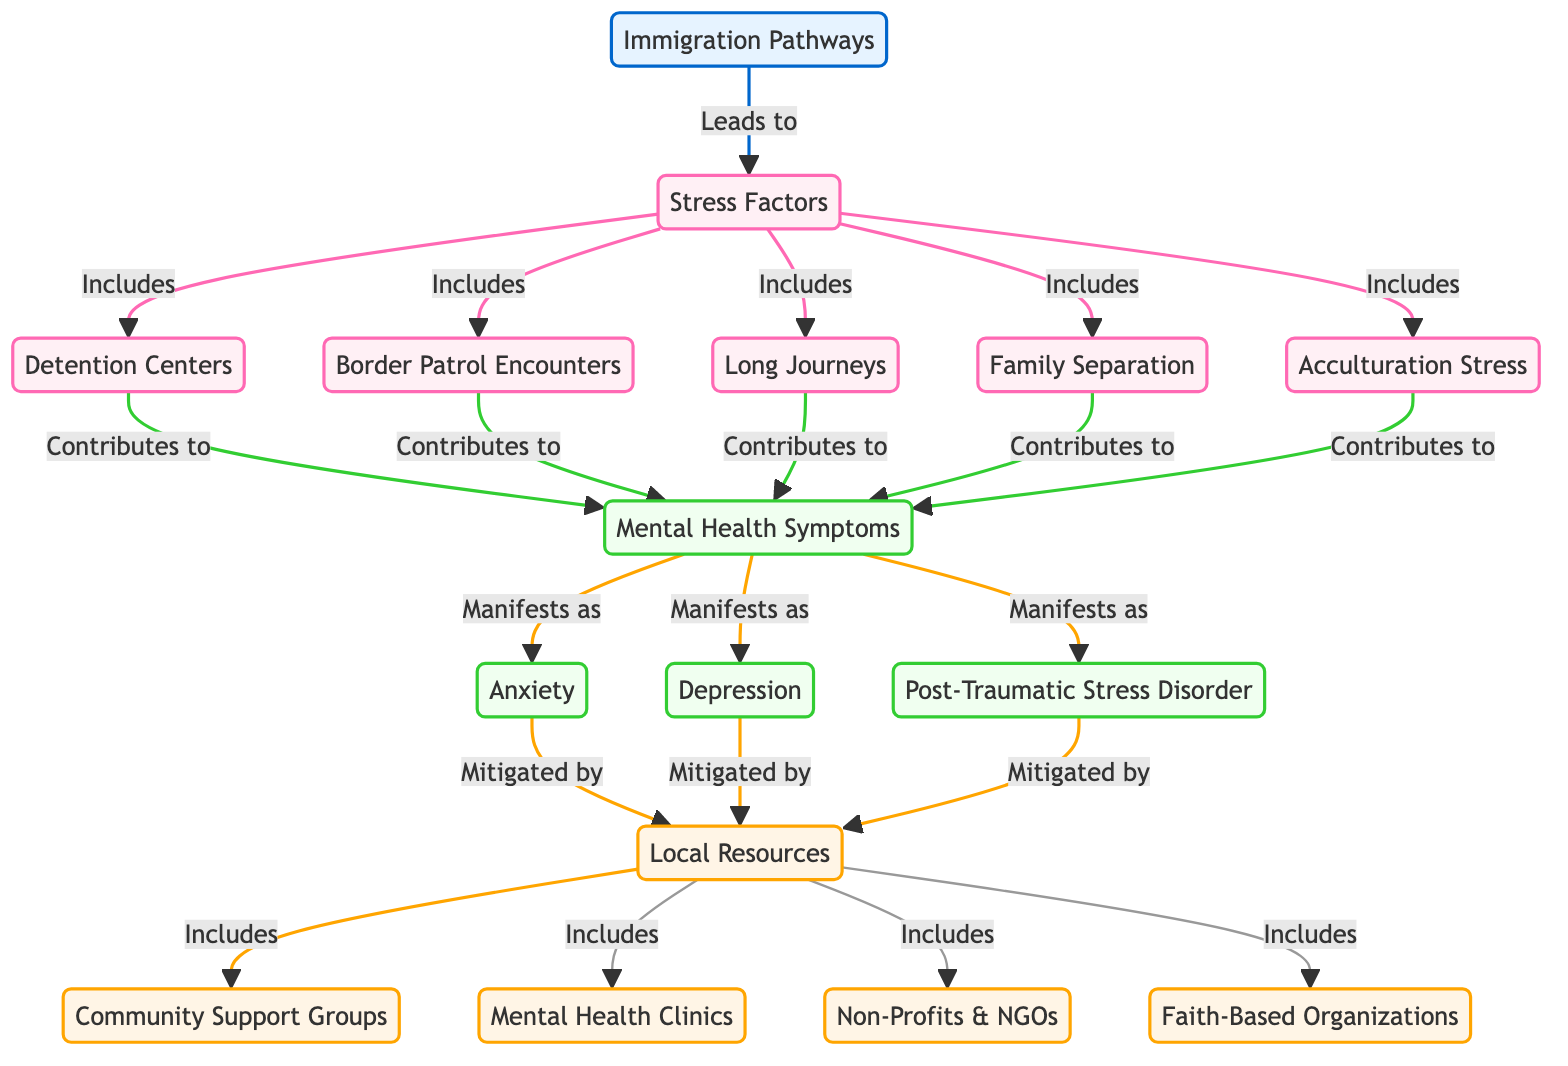What are the main stress factors related to immigration? The diagram lists the stress factors as: Detention Centers, Border Patrol Encounters, Long Journeys, Family Separation, and Acculturation Stress. These factors directly connect to the "Stress Factors" node, indicating they are crucial contributors to overall stress experienced by migrants.
Answer: Detention Centers, Border Patrol Encounters, Long Journeys, Family Separation, Acculturation Stress How many local resources are identified in the diagram? The diagram specifies four local resources: Community Support Groups, Mental Health Clinics, Non-Profits & NGOs, and Faith-Based Organizations. These are all linked to the "Local Resources" node, confirming they are vital support options available.
Answer: Four What symptoms are associated with mental health issues in migrants? The symptoms indicated in the diagram are Anxiety, Depression, and Post-Traumatic Stress Disorder. Each of these is connected to the "Mental Health Symptoms" node, demonstrating their significance in the context of mental health for migrants.
Answer: Anxiety, Depression, Post-Traumatic Stress Disorder Which stress factor contributes to mental health symptoms? Detention Centers, Border Patrol Encounters, Long Journeys, Family Separation, and Acculturation Stress are the factors that contribute to mental health symptoms, as shown by their direct connection to the "Mental Health Symptoms" node.
Answer: Detention Centers, Border Patrol Encounters, Long Journeys, Family Separation, Acculturation Stress What is the flow from immigration pathways to local resources? The diagram shows that Immigration Pathways lead to Stress Factors, which in turn contribute to Mental Health Symptoms. Finally, these symptoms are mitigated by Local Resources, illustrating a clear progression from immigration to available support mechanisms.
Answer: Immigration Pathways to Local Resources How do mental health symptoms manifest according to the diagram? The diagram indicates that stress factors lead to Mental Health Symptoms, which are specifically Anxiety, Depression, and Post-Traumatic Stress Disorder. This shows a direct manifestation of symptoms stemming from identified stressors in the immigrant experience.
Answer: Anxiety, Depression, Post-Traumatic Stress Disorder What type of organizations are included in local resources? The local resources include Community Support Groups, Mental Health Clinics, Non-Profits & NGOs, and Faith-Based Organizations. These are types of organizations aimed at providing support to individuals experiencing mental health issues related to immigration and border crossings.
Answer: Community Support Groups, Mental Health Clinics, Non-Profits & NGOs, Faith-Based Organizations 